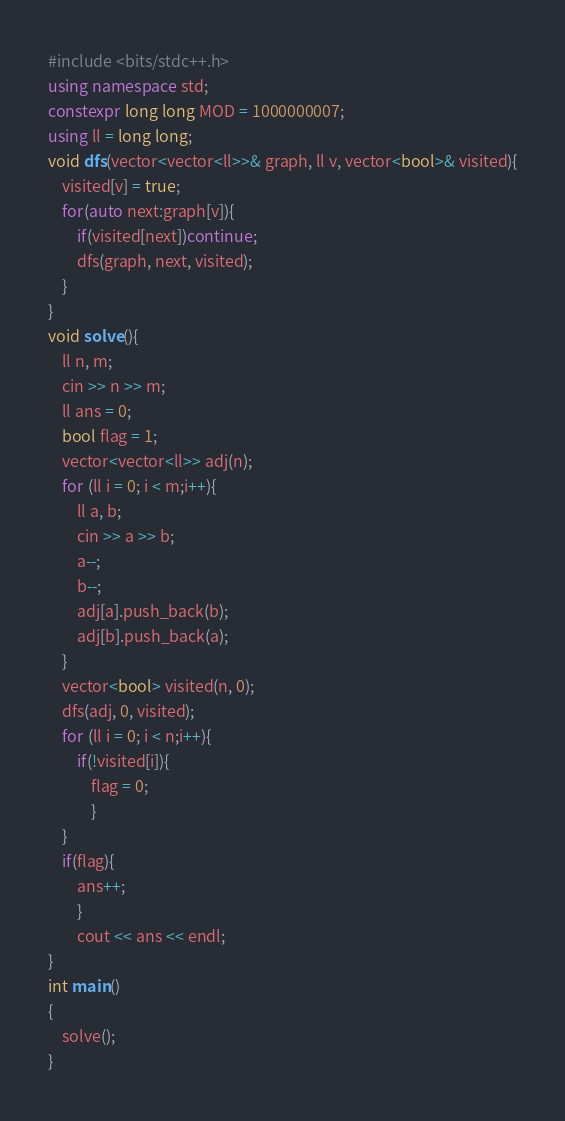Convert code to text. <code><loc_0><loc_0><loc_500><loc_500><_C++_>#include <bits/stdc++.h>
using namespace std;
constexpr long long MOD = 1000000007;
using ll = long long;
void dfs(vector<vector<ll>>& graph, ll v, vector<bool>& visited){
    visited[v] = true;
    for(auto next:graph[v]){
        if(visited[next])continue;
        dfs(graph, next, visited);
    }
}
void solve(){
    ll n, m;
    cin >> n >> m;
    ll ans = 0;
    bool flag = 1;
    vector<vector<ll>> adj(n);
    for (ll i = 0; i < m;i++){
        ll a, b;
        cin >> a >> b;
        a--;
        b--;
        adj[a].push_back(b);
        adj[b].push_back(a);
    }
    vector<bool> visited(n, 0);
    dfs(adj, 0, visited);
    for (ll i = 0; i < n;i++){
        if(!visited[i]){
            flag = 0;
            }
    }
    if(flag){
        ans++;
        }
        cout << ans << endl;
}
int main()
{
    solve();
}
</code> 